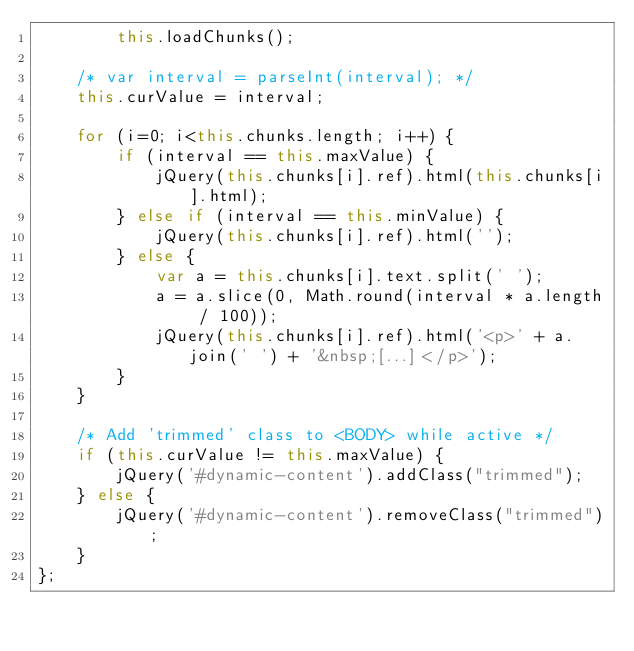Convert code to text. <code><loc_0><loc_0><loc_500><loc_500><_JavaScript_>		this.loadChunks();

	/* var interval = parseInt(interval); */
	this.curValue = interval;

	for (i=0; i<this.chunks.length; i++) {
		if (interval == this.maxValue) {
			jQuery(this.chunks[i].ref).html(this.chunks[i].html);
		} else if (interval == this.minValue) {
			jQuery(this.chunks[i].ref).html('');
		} else {
			var a = this.chunks[i].text.split(' ');
			a = a.slice(0, Math.round(interval * a.length / 100));
			jQuery(this.chunks[i].ref).html('<p>' + a.join(' ') + '&nbsp;[...]</p>');
		}
	}

	/* Add 'trimmed' class to <BODY> while active */
	if (this.curValue != this.maxValue) {
		jQuery('#dynamic-content').addClass("trimmed");
	} else {
		jQuery('#dynamic-content').removeClass("trimmed");
	}
};</code> 